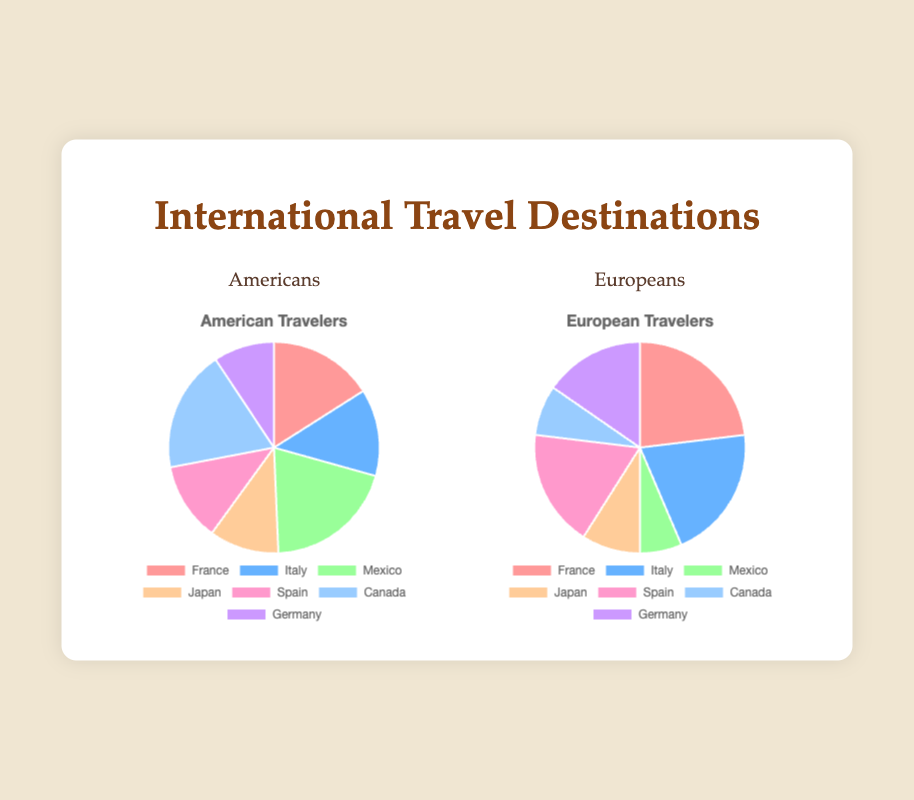Which destination is more popular with Americans than Europeans? By comparing the data points visually, Mexico and Canada are more popular with Americans than Europeans.
Answer: Mexico and Canada What is the total number of Americans traveling to France and Italy? To find the total, sum the number of American travelers to France (12) and Italy (10). So, 12 + 10 = 22.
Answer: 22 Which destination has the most significant difference in popularity between Americans and Europeans? By analyzing the differences visually, France has 6 more Europeans (18) than Americans (12), and Mexico has 10 more Americans (15) than Europeans (5). Mexico has the most significant difference.
Answer: Mexico Which destination is equally popular with both Americans and Europeans? By examining the chart, no destinations have exact equal values for Americans and Europeans.
Answer: None Compare the popularity of Germany between Americans and Europeans. Germany is more popular with Europeans (12) than Americans (7).
Answer: Europeans What is the difference in the number of Americans traveling to Japan and Canada? Subtract the number of American travelers to Japan (8) from that to Canada (14). So, 14 - 8 = 6.
Answer: 6 What percentage of American travelers chose Canada? The total number of American travelers is 75. The percentage for Canada is (14/75) * 100 ≈ 18.67%.
Answer: 18.67% What color represents Spain in the American travelers' chart? By looking at the color coding in the American chart, Spain is represented by the color light green.
Answer: Light green Which destination do Europeans prefer the most? By comparing the heights of the slices in the European travelers' pie chart, France is preferred the most by Europeans.
Answer: France What is the sum of travelers going to Canada and Germany for both Americans and Europeans? Sum the values for both destinations: 14 (Americans to Canada) + 6 (Europeans to Canada) + 7 (Americans to Germany) + 12 (Europeans to Germany). So, 14 + 6 + 7 + 12 = 39.
Answer: 39 